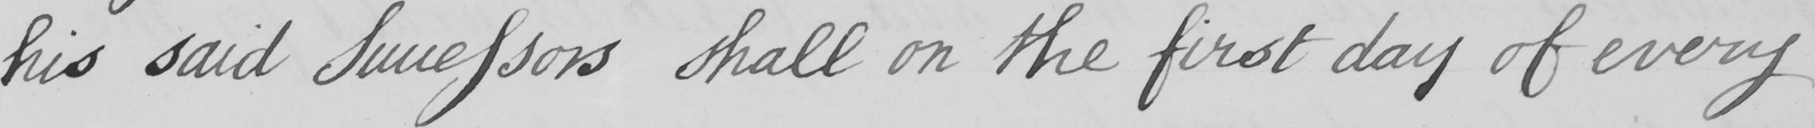What is written in this line of handwriting? his said Successors shall on the first day of every 